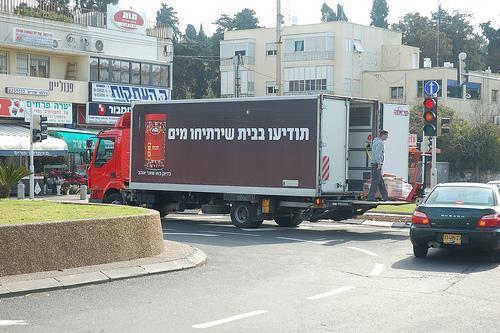How many vehicles are in the image?
Give a very brief answer. 2. 